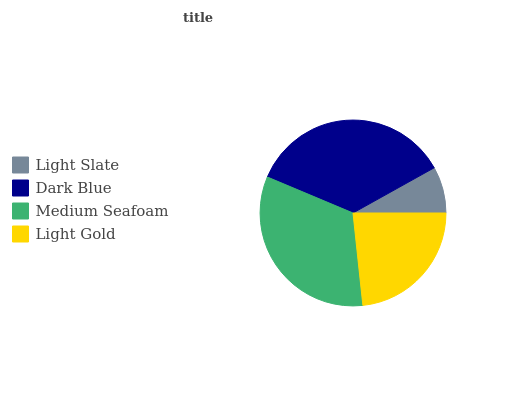Is Light Slate the minimum?
Answer yes or no. Yes. Is Dark Blue the maximum?
Answer yes or no. Yes. Is Medium Seafoam the minimum?
Answer yes or no. No. Is Medium Seafoam the maximum?
Answer yes or no. No. Is Dark Blue greater than Medium Seafoam?
Answer yes or no. Yes. Is Medium Seafoam less than Dark Blue?
Answer yes or no. Yes. Is Medium Seafoam greater than Dark Blue?
Answer yes or no. No. Is Dark Blue less than Medium Seafoam?
Answer yes or no. No. Is Medium Seafoam the high median?
Answer yes or no. Yes. Is Light Gold the low median?
Answer yes or no. Yes. Is Dark Blue the high median?
Answer yes or no. No. Is Medium Seafoam the low median?
Answer yes or no. No. 